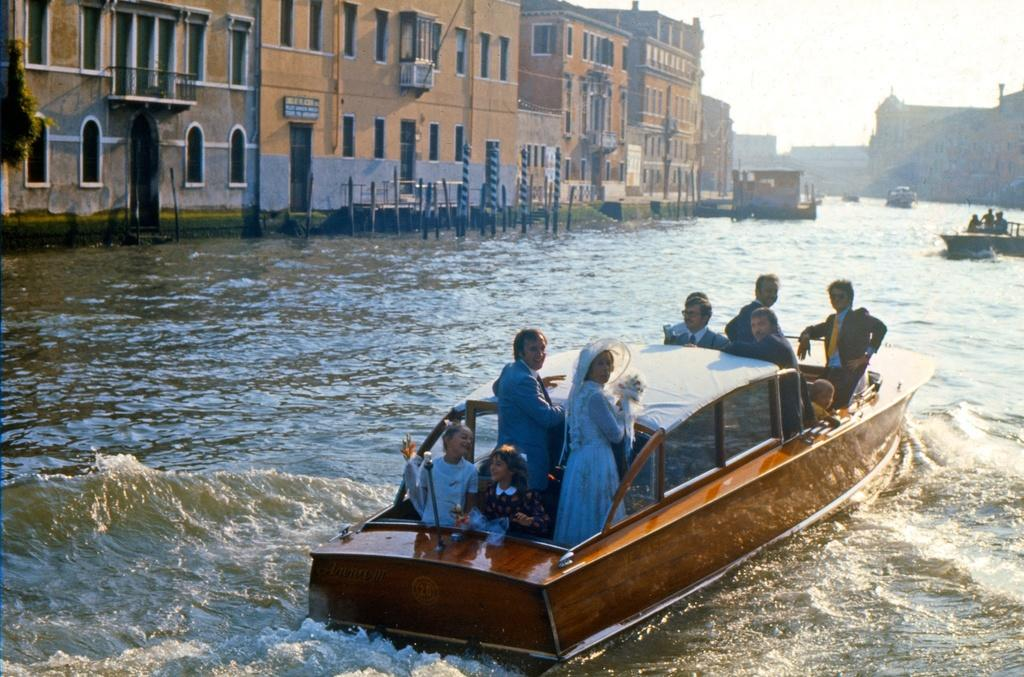What are the people in the image doing? The people in the image are sailing on boats. What can be seen in the background of the image? There are buildings visible in the image. What objects are present in the water in the image? There are poles in the water in the image. What is visible above the water in the image? The sky is visible in the image. What type of neck can be seen on the bear in the image? There is no bear present in the image, so it is not possible to determine the type of neck. 